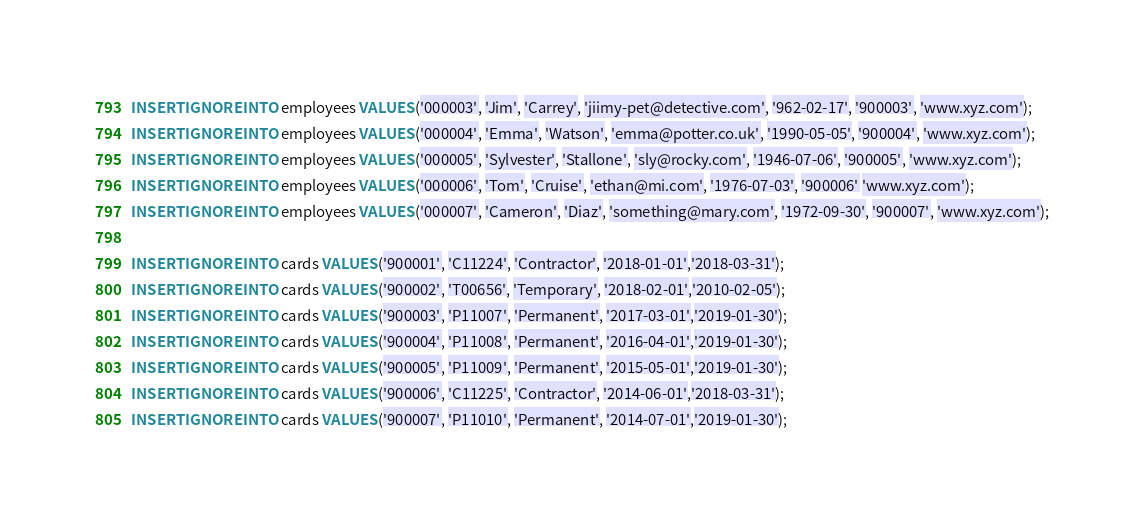Convert code to text. <code><loc_0><loc_0><loc_500><loc_500><_SQL_>INSERT IGNORE INTO employees VALUES ('000003', 'Jim', 'Carrey', 'jiimy-pet@detective.com', '962-02-17', '900003', 'www.xyz.com');
INSERT IGNORE INTO employees VALUES ('000004', 'Emma', 'Watson', 'emma@potter.co.uk', '1990-05-05', '900004', 'www.xyz.com');
INSERT IGNORE INTO employees VALUES ('000005', 'Sylvester', 'Stallone', 'sly@rocky.com', '1946-07-06', '900005', 'www.xyz.com');
INSERT IGNORE INTO employees VALUES ('000006', 'Tom', 'Cruise', 'ethan@mi.com', '1976-07-03', '900006' 'www.xyz.com');
INSERT IGNORE INTO employees VALUES ('000007', 'Cameron', 'Diaz', 'something@mary.com', '1972-09-30', '900007', 'www.xyz.com');

INSERT IGNORE INTO cards VALUES ('900001', 'C11224', 'Contractor', '2018-01-01','2018-03-31');
INSERT IGNORE INTO cards VALUES ('900002', 'T00656', 'Temporary', '2018-02-01','2010-02-05');
INSERT IGNORE INTO cards VALUES ('900003', 'P11007', 'Permanent', '2017-03-01','2019-01-30');
INSERT IGNORE INTO cards VALUES ('900004', 'P11008', 'Permanent', '2016-04-01','2019-01-30');
INSERT IGNORE INTO cards VALUES ('900005', 'P11009', 'Permanent', '2015-05-01','2019-01-30');
INSERT IGNORE INTO cards VALUES ('900006', 'C11225', 'Contractor', '2014-06-01','2018-03-31');
INSERT IGNORE INTO cards VALUES ('900007', 'P11010', 'Permanent', '2014-07-01','2019-01-30');

</code> 